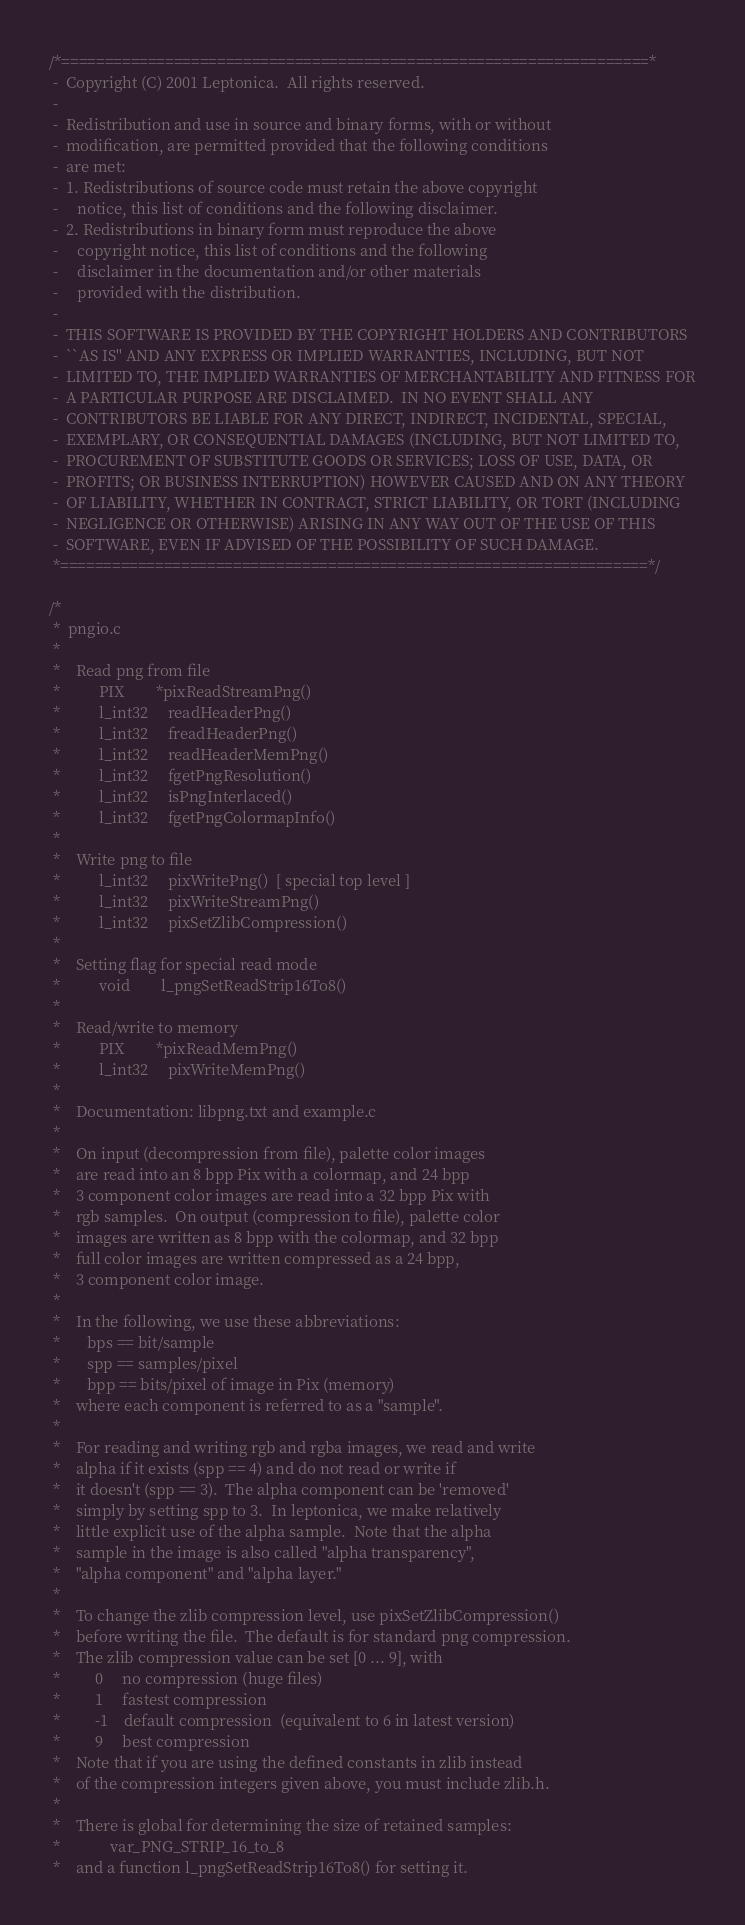<code> <loc_0><loc_0><loc_500><loc_500><_C_>/*====================================================================*
 -  Copyright (C) 2001 Leptonica.  All rights reserved.
 -
 -  Redistribution and use in source and binary forms, with or without
 -  modification, are permitted provided that the following conditions
 -  are met:
 -  1. Redistributions of source code must retain the above copyright
 -     notice, this list of conditions and the following disclaimer.
 -  2. Redistributions in binary form must reproduce the above
 -     copyright notice, this list of conditions and the following
 -     disclaimer in the documentation and/or other materials
 -     provided with the distribution.
 -
 -  THIS SOFTWARE IS PROVIDED BY THE COPYRIGHT HOLDERS AND CONTRIBUTORS
 -  ``AS IS'' AND ANY EXPRESS OR IMPLIED WARRANTIES, INCLUDING, BUT NOT
 -  LIMITED TO, THE IMPLIED WARRANTIES OF MERCHANTABILITY AND FITNESS FOR
 -  A PARTICULAR PURPOSE ARE DISCLAIMED.  IN NO EVENT SHALL ANY
 -  CONTRIBUTORS BE LIABLE FOR ANY DIRECT, INDIRECT, INCIDENTAL, SPECIAL,
 -  EXEMPLARY, OR CONSEQUENTIAL DAMAGES (INCLUDING, BUT NOT LIMITED TO,
 -  PROCUREMENT OF SUBSTITUTE GOODS OR SERVICES; LOSS OF USE, DATA, OR
 -  PROFITS; OR BUSINESS INTERRUPTION) HOWEVER CAUSED AND ON ANY THEORY
 -  OF LIABILITY, WHETHER IN CONTRACT, STRICT LIABILITY, OR TORT (INCLUDING
 -  NEGLIGENCE OR OTHERWISE) ARISING IN ANY WAY OUT OF THE USE OF THIS
 -  SOFTWARE, EVEN IF ADVISED OF THE POSSIBILITY OF SUCH DAMAGE.
 *====================================================================*/

/*
 *  pngio.c
 *
 *    Read png from file
 *          PIX        *pixReadStreamPng()
 *          l_int32     readHeaderPng()
 *          l_int32     freadHeaderPng()
 *          l_int32     readHeaderMemPng()
 *          l_int32     fgetPngResolution()
 *          l_int32     isPngInterlaced()
 *          l_int32     fgetPngColormapInfo()
 *
 *    Write png to file
 *          l_int32     pixWritePng()  [ special top level ]
 *          l_int32     pixWriteStreamPng()
 *          l_int32     pixSetZlibCompression()
 *
 *    Setting flag for special read mode
 *          void        l_pngSetReadStrip16To8()
 *
 *    Read/write to memory
 *          PIX        *pixReadMemPng()
 *          l_int32     pixWriteMemPng()
 *
 *    Documentation: libpng.txt and example.c
 *
 *    On input (decompression from file), palette color images
 *    are read into an 8 bpp Pix with a colormap, and 24 bpp
 *    3 component color images are read into a 32 bpp Pix with
 *    rgb samples.  On output (compression to file), palette color
 *    images are written as 8 bpp with the colormap, and 32 bpp
 *    full color images are written compressed as a 24 bpp,
 *    3 component color image.
 *
 *    In the following, we use these abbreviations:
 *       bps == bit/sample
 *       spp == samples/pixel
 *       bpp == bits/pixel of image in Pix (memory)
 *    where each component is referred to as a "sample".
 *
 *    For reading and writing rgb and rgba images, we read and write
 *    alpha if it exists (spp == 4) and do not read or write if
 *    it doesn't (spp == 3).  The alpha component can be 'removed'
 *    simply by setting spp to 3.  In leptonica, we make relatively
 *    little explicit use of the alpha sample.  Note that the alpha
 *    sample in the image is also called "alpha transparency",
 *    "alpha component" and "alpha layer."
 *
 *    To change the zlib compression level, use pixSetZlibCompression()
 *    before writing the file.  The default is for standard png compression.
 *    The zlib compression value can be set [0 ... 9], with
 *         0     no compression (huge files)
 *         1     fastest compression
 *         -1    default compression  (equivalent to 6 in latest version)
 *         9     best compression
 *    Note that if you are using the defined constants in zlib instead
 *    of the compression integers given above, you must include zlib.h.
 *
 *    There is global for determining the size of retained samples:
 *             var_PNG_STRIP_16_to_8
 *    and a function l_pngSetReadStrip16To8() for setting it.</code> 